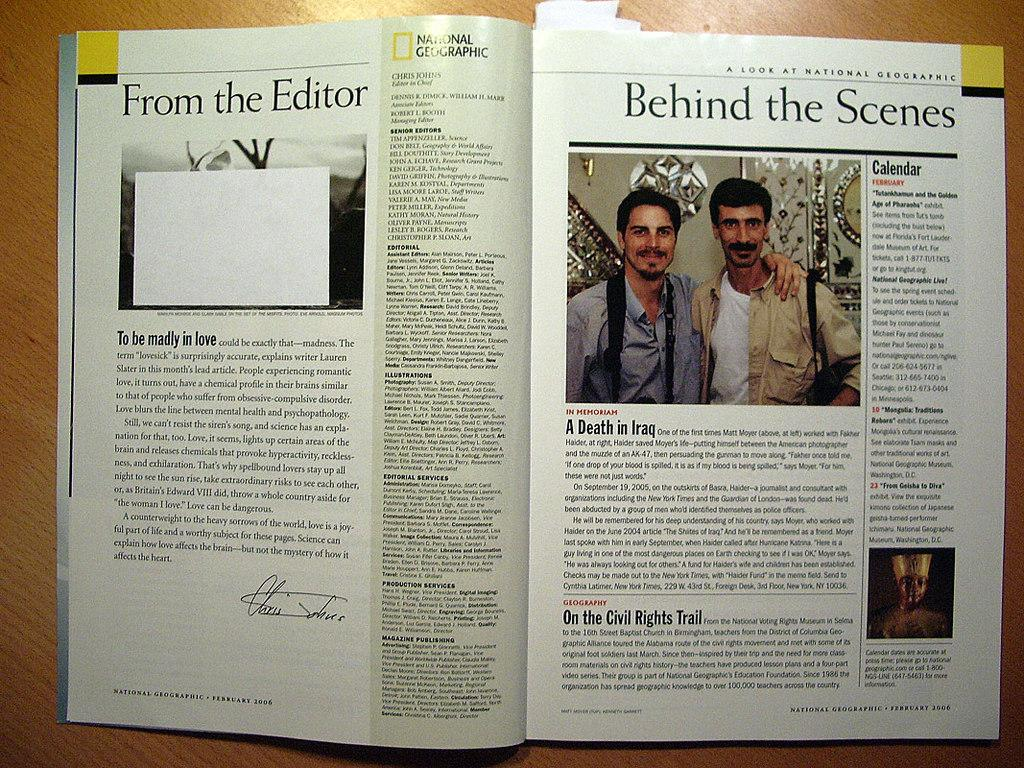<image>
Describe the image concisely. The inside of a National Geographic magazine that shows a commentary on Iraq and the Civil Rights movement. 